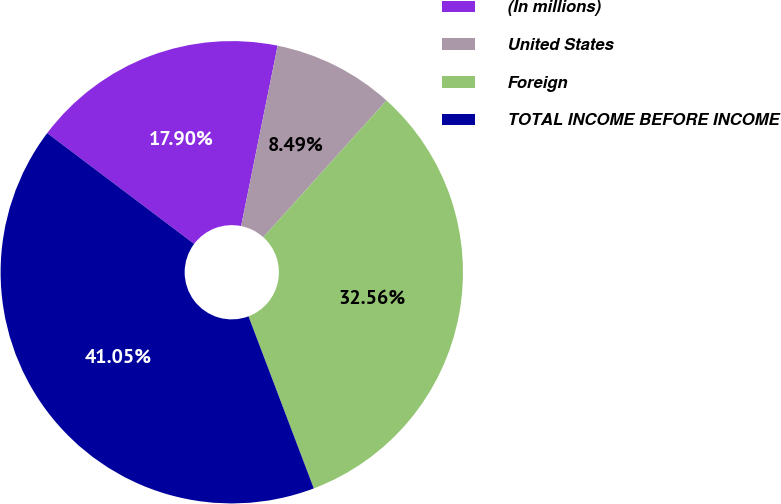<chart> <loc_0><loc_0><loc_500><loc_500><pie_chart><fcel>(In millions)<fcel>United States<fcel>Foreign<fcel>TOTAL INCOME BEFORE INCOME<nl><fcel>17.9%<fcel>8.49%<fcel>32.56%<fcel>41.05%<nl></chart> 